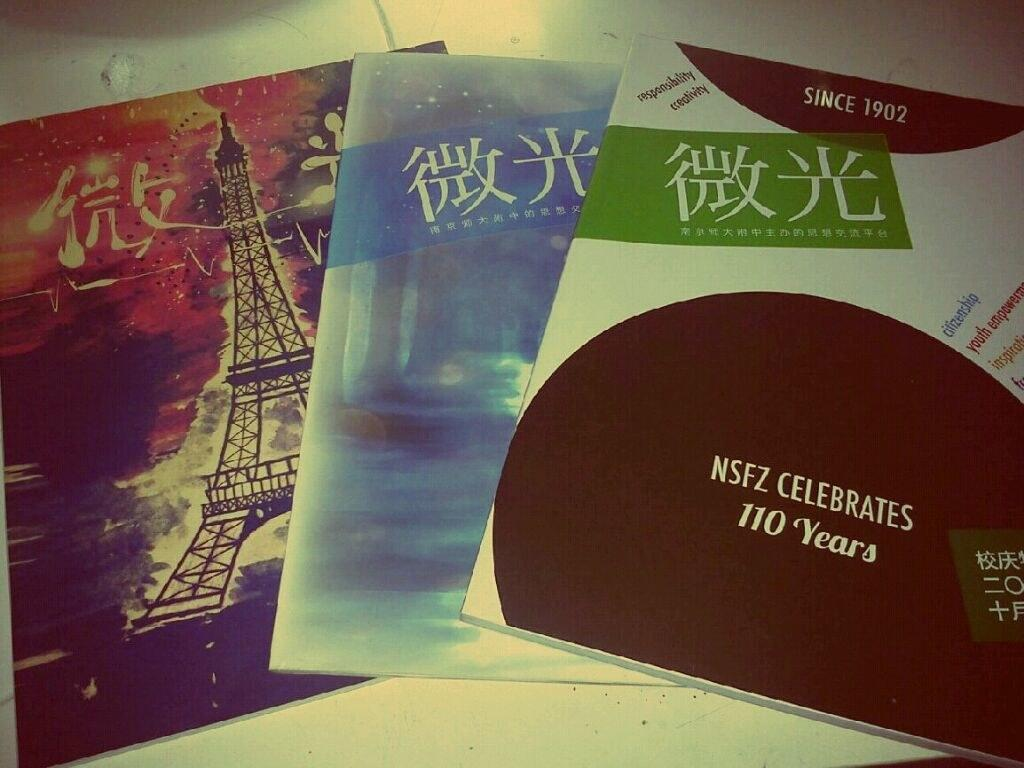Provide a one-sentence caption for the provided image. The company is celebrating a 110 years of doing business. 